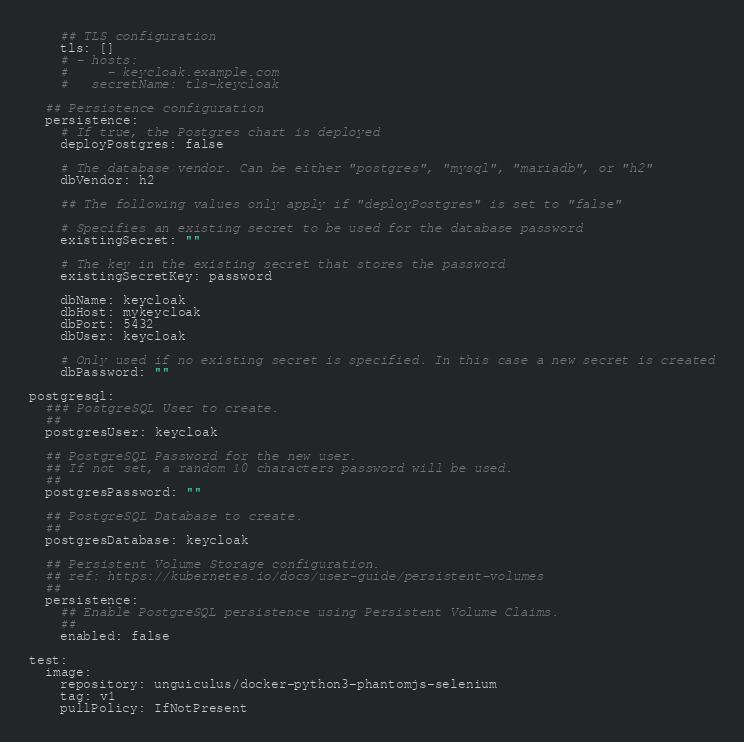<code> <loc_0><loc_0><loc_500><loc_500><_YAML_>
    ## TLS configuration
    tls: []
    # - hosts:
    #     - keycloak.example.com
    #   secretName: tls-keycloak

  ## Persistence configuration
  persistence:
    # If true, the Postgres chart is deployed
    deployPostgres: false

    # The database vendor. Can be either "postgres", "mysql", "mariadb", or "h2"
    dbVendor: h2

    ## The following values only apply if "deployPostgres" is set to "false"

    # Specifies an existing secret to be used for the database password
    existingSecret: ""

    # The key in the existing secret that stores the password
    existingSecretKey: password

    dbName: keycloak
    dbHost: mykeycloak
    dbPort: 5432
    dbUser: keycloak

    # Only used if no existing secret is specified. In this case a new secret is created
    dbPassword: ""

postgresql:
  ### PostgreSQL User to create.
  ##
  postgresUser: keycloak

  ## PostgreSQL Password for the new user.
  ## If not set, a random 10 characters password will be used.
  ##
  postgresPassword: ""

  ## PostgreSQL Database to create.
  ##
  postgresDatabase: keycloak

  ## Persistent Volume Storage configuration.
  ## ref: https://kubernetes.io/docs/user-guide/persistent-volumes
  ##
  persistence:
    ## Enable PostgreSQL persistence using Persistent Volume Claims.
    ##
    enabled: false

test:
  image:
    repository: unguiculus/docker-python3-phantomjs-selenium
    tag: v1
    pullPolicy: IfNotPresent
</code> 